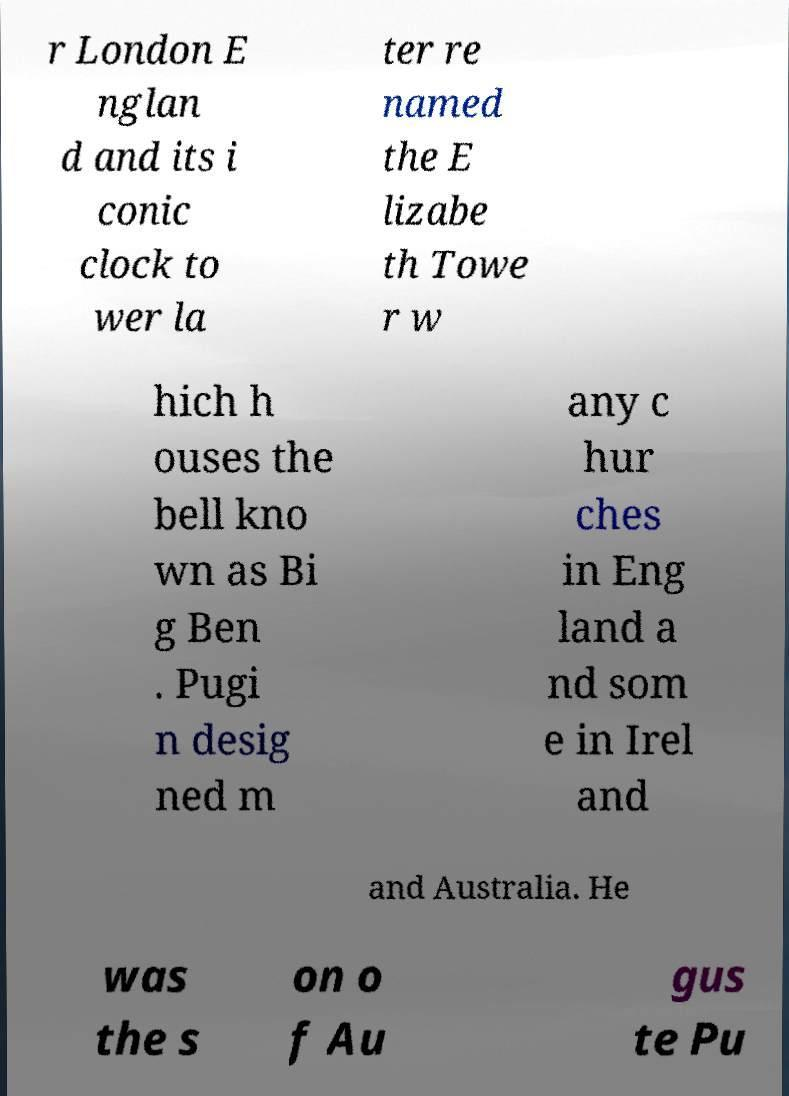Can you read and provide the text displayed in the image?This photo seems to have some interesting text. Can you extract and type it out for me? r London E nglan d and its i conic clock to wer la ter re named the E lizabe th Towe r w hich h ouses the bell kno wn as Bi g Ben . Pugi n desig ned m any c hur ches in Eng land a nd som e in Irel and and Australia. He was the s on o f Au gus te Pu 